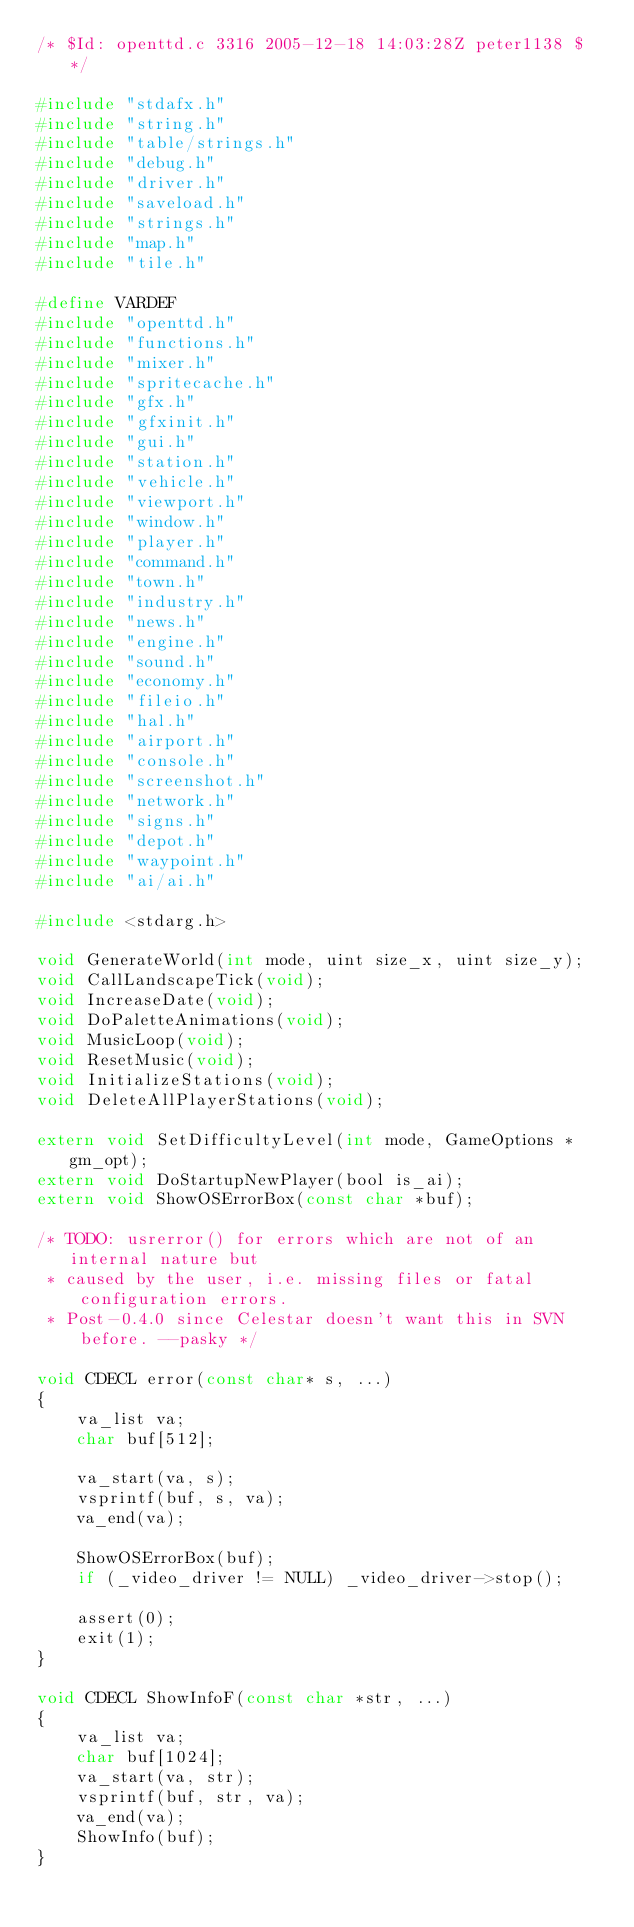<code> <loc_0><loc_0><loc_500><loc_500><_C_>/* $Id: openttd.c 3316 2005-12-18 14:03:28Z peter1138 $ */

#include "stdafx.h"
#include "string.h"
#include "table/strings.h"
#include "debug.h"
#include "driver.h"
#include "saveload.h"
#include "strings.h"
#include "map.h"
#include "tile.h"

#define VARDEF
#include "openttd.h"
#include "functions.h"
#include "mixer.h"
#include "spritecache.h"
#include "gfx.h"
#include "gfxinit.h"
#include "gui.h"
#include "station.h"
#include "vehicle.h"
#include "viewport.h"
#include "window.h"
#include "player.h"
#include "command.h"
#include "town.h"
#include "industry.h"
#include "news.h"
#include "engine.h"
#include "sound.h"
#include "economy.h"
#include "fileio.h"
#include "hal.h"
#include "airport.h"
#include "console.h"
#include "screenshot.h"
#include "network.h"
#include "signs.h"
#include "depot.h"
#include "waypoint.h"
#include "ai/ai.h"

#include <stdarg.h>

void GenerateWorld(int mode, uint size_x, uint size_y);
void CallLandscapeTick(void);
void IncreaseDate(void);
void DoPaletteAnimations(void);
void MusicLoop(void);
void ResetMusic(void);
void InitializeStations(void);
void DeleteAllPlayerStations(void);

extern void SetDifficultyLevel(int mode, GameOptions *gm_opt);
extern void DoStartupNewPlayer(bool is_ai);
extern void ShowOSErrorBox(const char *buf);

/* TODO: usrerror() for errors which are not of an internal nature but
 * caused by the user, i.e. missing files or fatal configuration errors.
 * Post-0.4.0 since Celestar doesn't want this in SVN before. --pasky */

void CDECL error(const char* s, ...)
{
	va_list va;
	char buf[512];

	va_start(va, s);
	vsprintf(buf, s, va);
	va_end(va);

	ShowOSErrorBox(buf);
	if (_video_driver != NULL) _video_driver->stop();

	assert(0);
	exit(1);
}

void CDECL ShowInfoF(const char *str, ...)
{
	va_list va;
	char buf[1024];
	va_start(va, str);
	vsprintf(buf, str, va);
	va_end(va);
	ShowInfo(buf);
}

</code> 